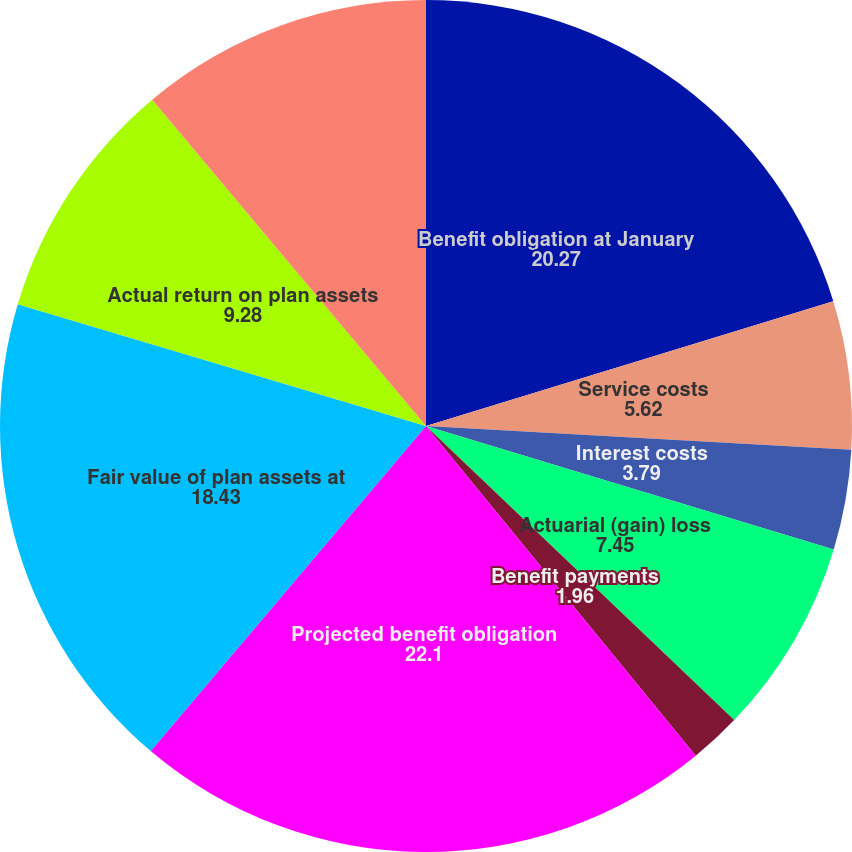Convert chart. <chart><loc_0><loc_0><loc_500><loc_500><pie_chart><fcel>Benefit obligation at January<fcel>Service costs<fcel>Interest costs<fcel>Actuarial (gain) loss<fcel>Benefit payments<fcel>Projected benefit obligation<fcel>Fair value of plan assets at<fcel>Actual return on plan assets<fcel>Employer contributions<nl><fcel>20.27%<fcel>5.62%<fcel>3.79%<fcel>7.45%<fcel>1.96%<fcel>22.1%<fcel>18.43%<fcel>9.28%<fcel>11.11%<nl></chart> 